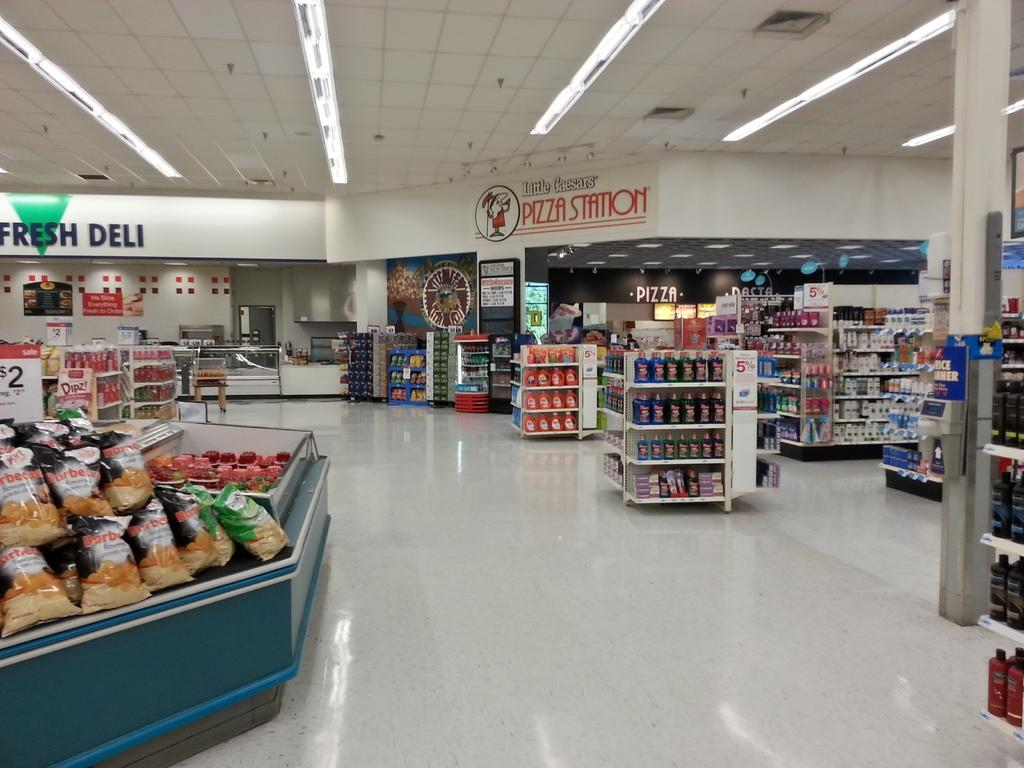Provide a one-sentence caption for the provided image. A little Caesar pizza store inside a supermarket. 